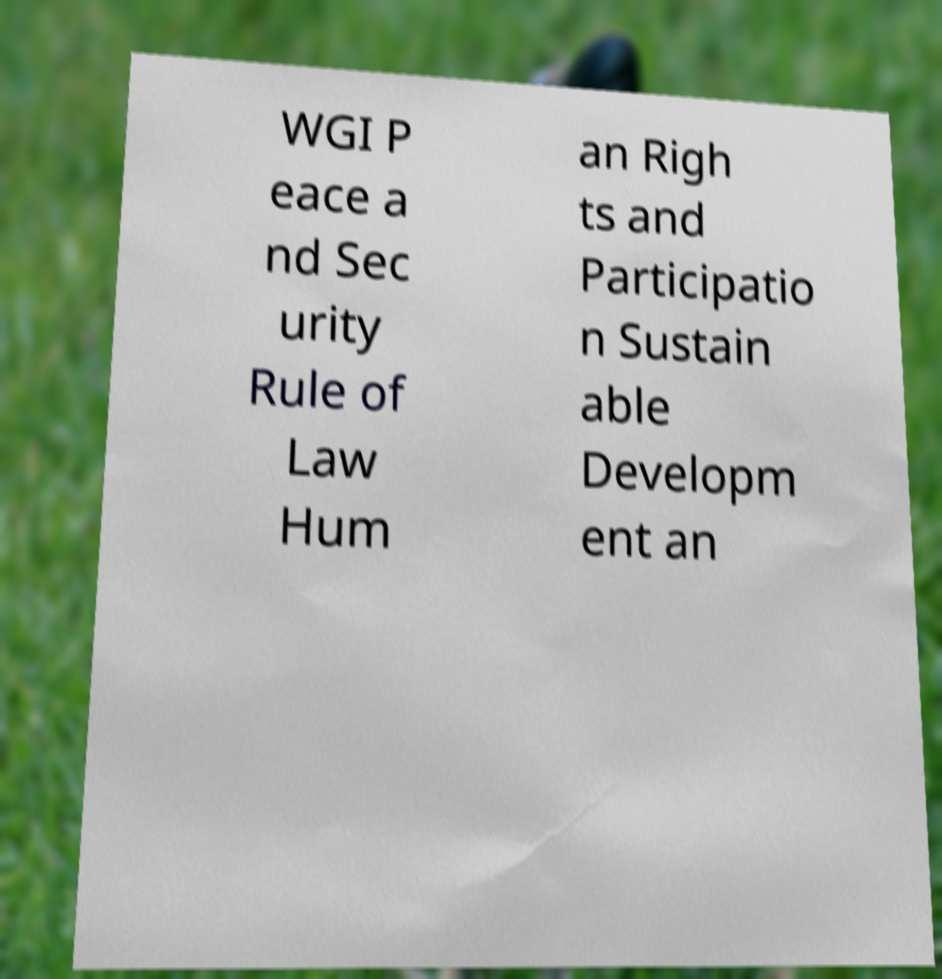Could you assist in decoding the text presented in this image and type it out clearly? WGI P eace a nd Sec urity Rule of Law Hum an Righ ts and Participatio n Sustain able Developm ent an 